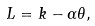Convert formula to latex. <formula><loc_0><loc_0><loc_500><loc_500>L = k - \alpha \theta ,</formula> 